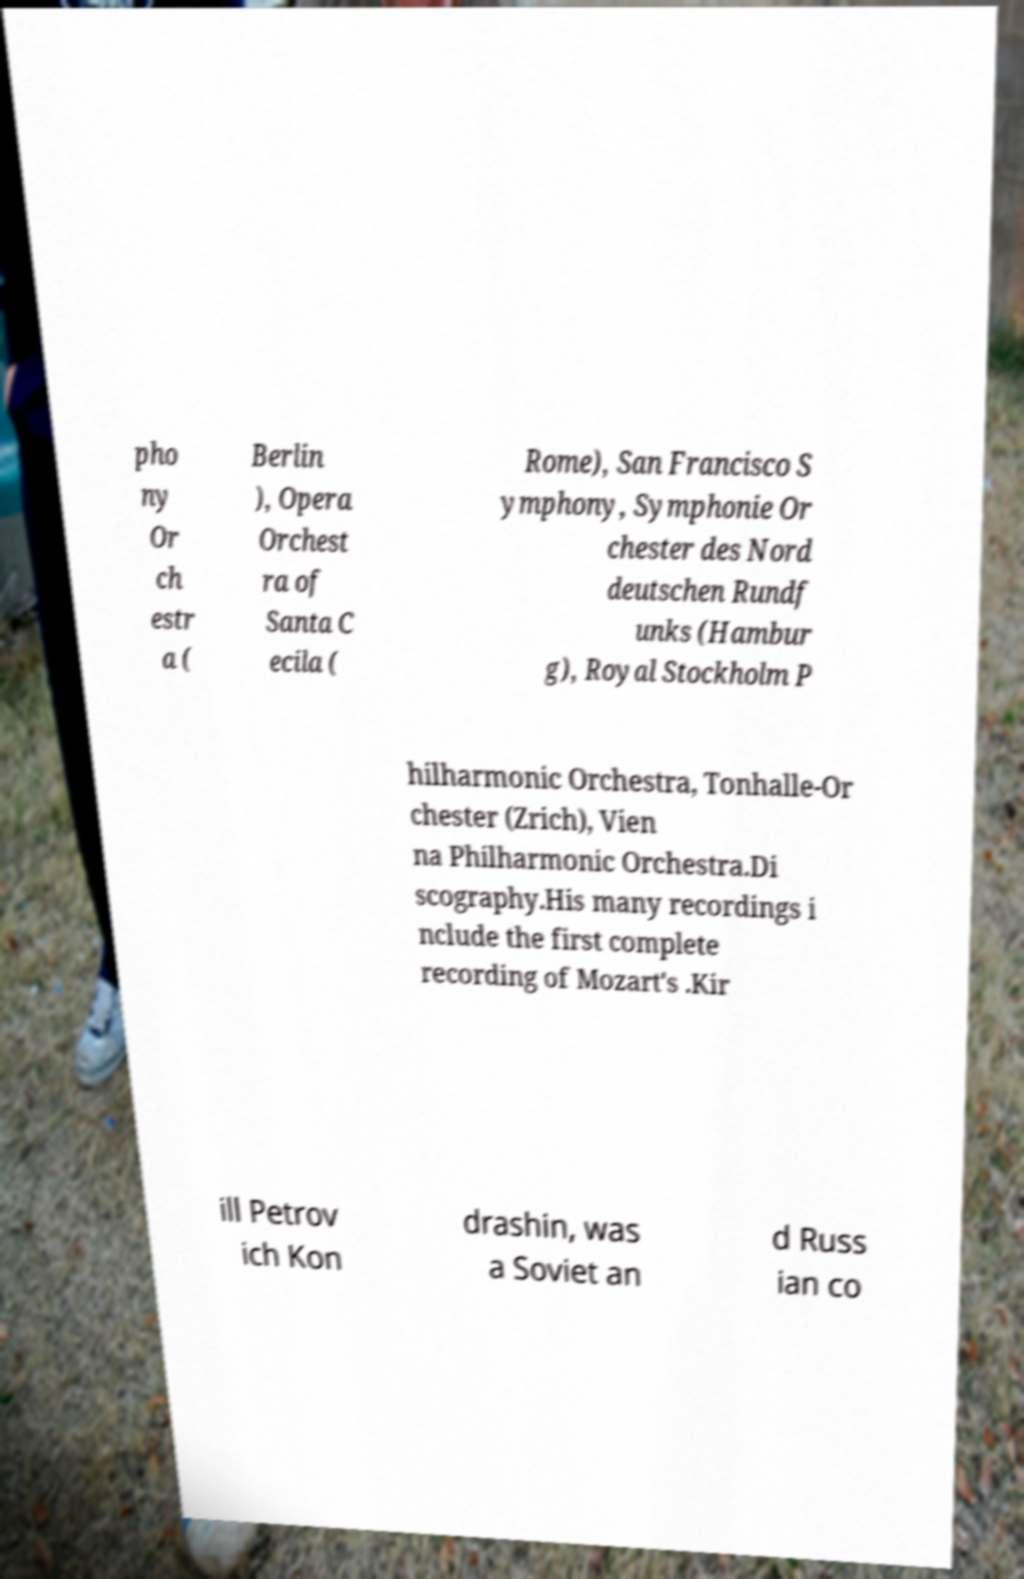What messages or text are displayed in this image? I need them in a readable, typed format. pho ny Or ch estr a ( Berlin ), Opera Orchest ra of Santa C ecila ( Rome), San Francisco S ymphony, Symphonie Or chester des Nord deutschen Rundf unks (Hambur g), Royal Stockholm P hilharmonic Orchestra, Tonhalle-Or chester (Zrich), Vien na Philharmonic Orchestra.Di scography.His many recordings i nclude the first complete recording of Mozart's .Kir ill Petrov ich Kon drashin, was a Soviet an d Russ ian co 